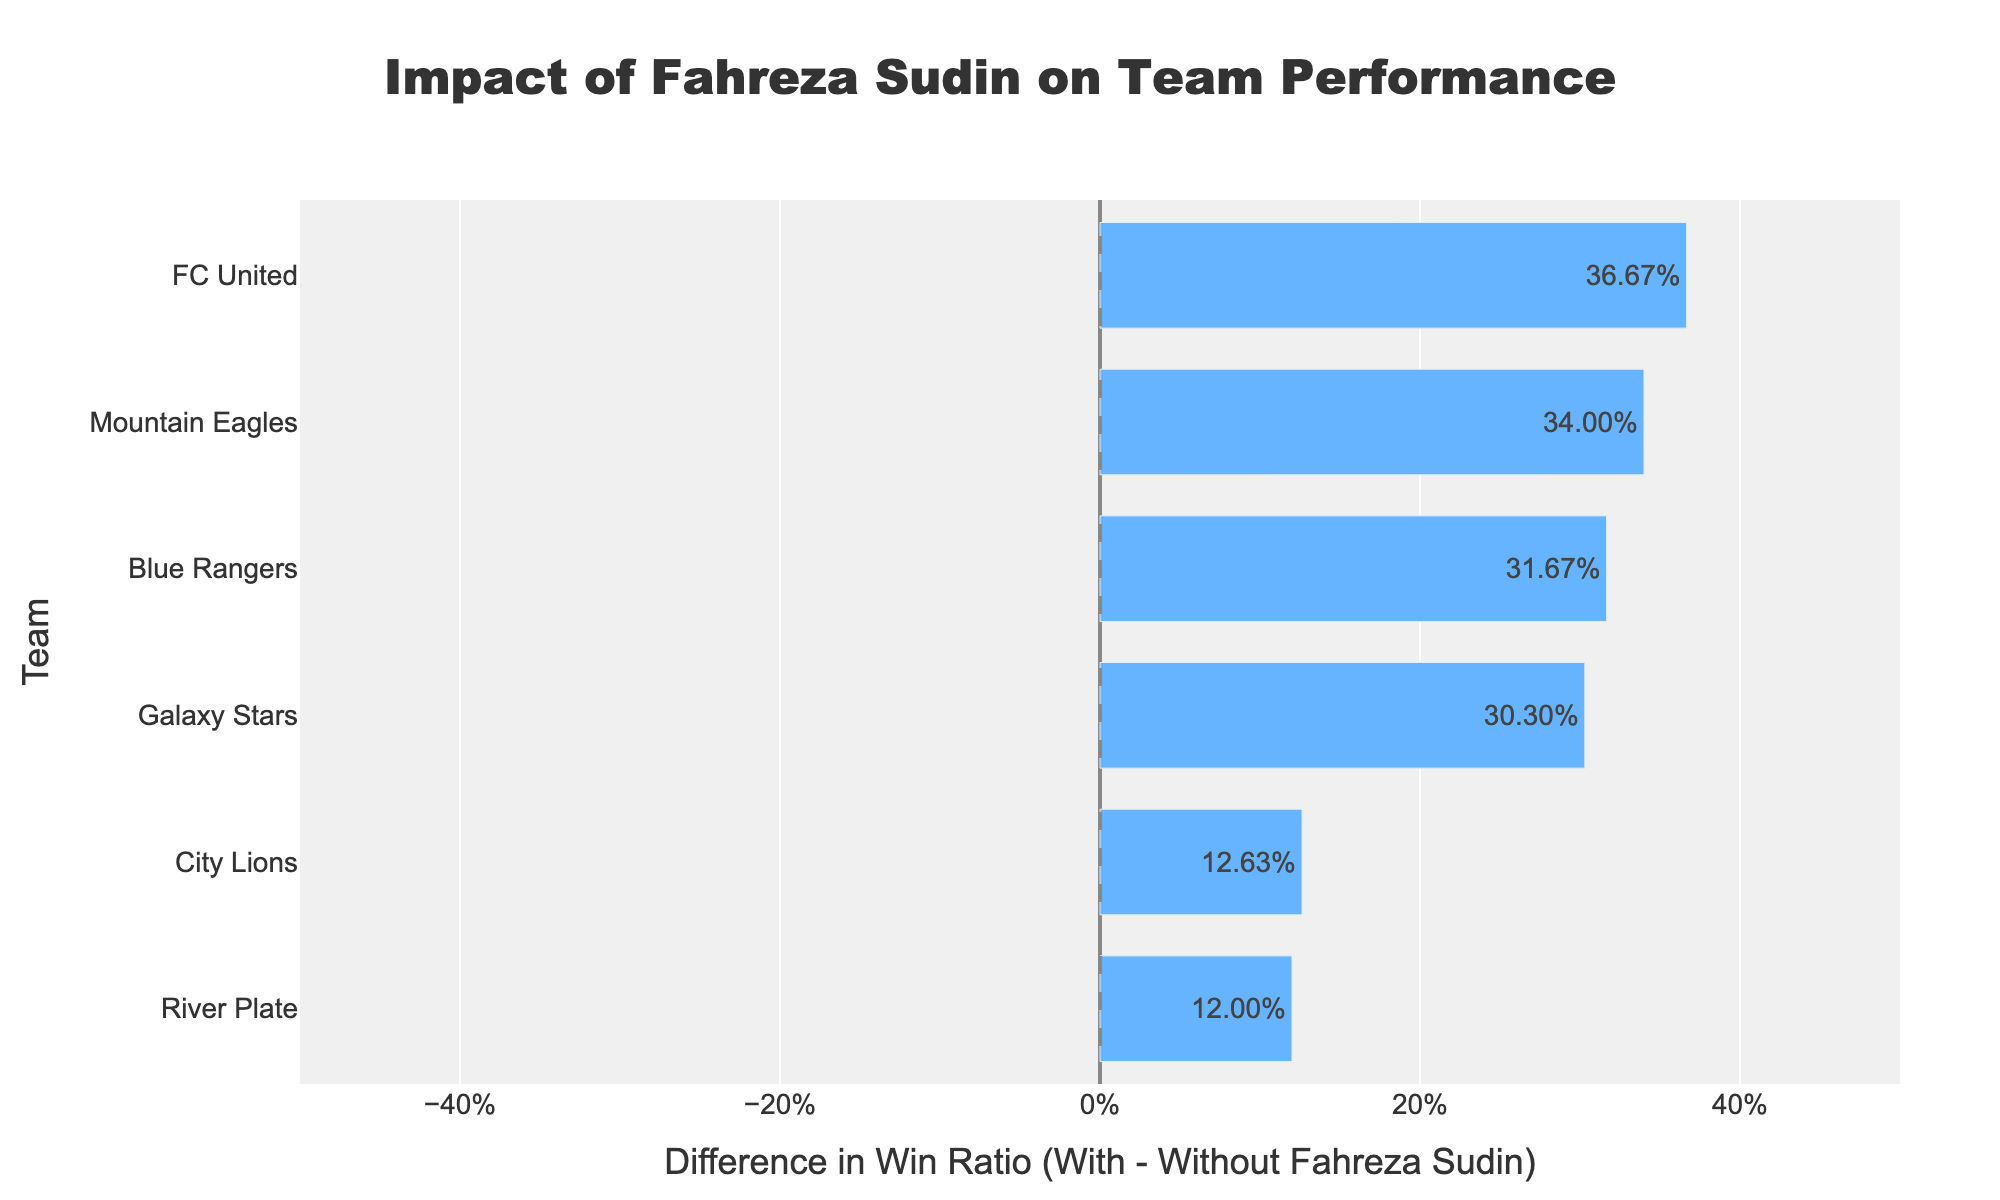Which team has the highest positive difference in win ratio with and without Fahreza Sudin? Identify the bar with the highest rightward extension. The longest bar in the positive direction corresponds to River Plate.
Answer: River Plate Which team shows a negative difference in win ratio with and without Fahreza Sudin? Identify the bar extending leftward (negative side). The team with the negative bar is Mountain Eagles.
Answer: Mountain Eagles How much is the difference in win ratios for Galaxy Stars with and without Fahreza Sudin? Locate Galaxy Stars and read the value of the bar connected to it. The difference is displayed as the bar's length or directly on the bar.
Answer: 0.14 What is the win ratio for FC United with Fahreza Sudin? Hover over the bar for FC United and look for the win ratio with Fahreza Sudin in the tooltip. It's specified as part of the detailed hover information.
Answer: 70% Compare the win ratios of Blue Rangers with and without Fahreza Sudin. Which is higher and by how much? Locate Blue Rangers and examine the tooltip or bar lengths. Calculate the difference: (Win ratio with Fahreza) - (Win ratio without Fahreza). Blue Rangers have a higher win ratio with Fahreza by the bar extending positively.
Answer: With Fahreza by 20% What is the overall trend seen for teams playing with Fahreza Sudin compared to without him? Observe the general direction and length of the bars. Most bars extend to the right, indicating a positive difference. This suggests a favorable impact of Fahreza on team win ratios.
Answer: Positive impact How many teams have a higher win ratio when playing without Fahreza Sudin than with him? Identify bars extending leftward from the zero baseline (negative direction). Only one team, Mountain Eagles, falls into this category.
Answer: One team Which team has the smallest positive difference in their win ratios with and without Fahreza Sudin? Look for the shortest bar extending rightward (positive side). In this case, City Lions have the shortest positive bar.
Answer: City Lions What is the color coding representing in the bar chart? Observe the colors used in the bars. Bars extending leftward are typically colored differently (e.g., red) compared to those extending rightward (e.g., blue). The color indicates negative (leftward) and positive (rightward) differences.
Answer: Negative: Red, Positive: Blue 